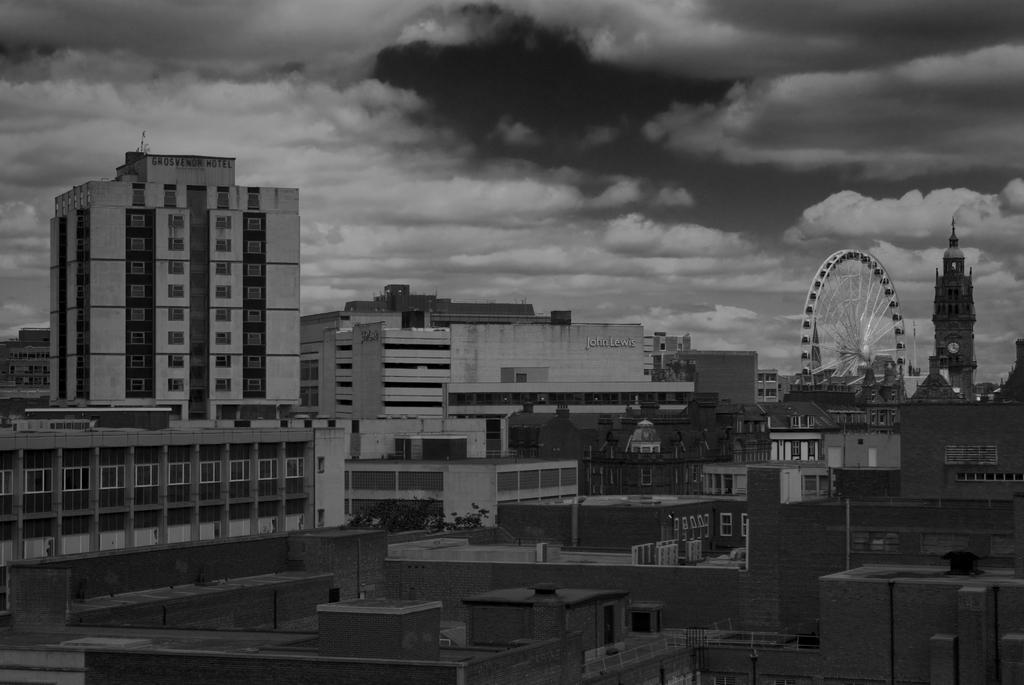What types of structures are present in the image? There are buildings and houses in the image. What type of amusement ride can be seen in the image? There is a giant wheel in the image. What is visible in the background of the image? The sky is visible in the image. What is the weather like in the image? The sky appears to be cloudy in the image. How many basketballs can be seen hanging from the buildings in the image? There are no basketballs present in the image. What type of birds are flying around the giant wheel in the image? There are no birds visible in the image. 